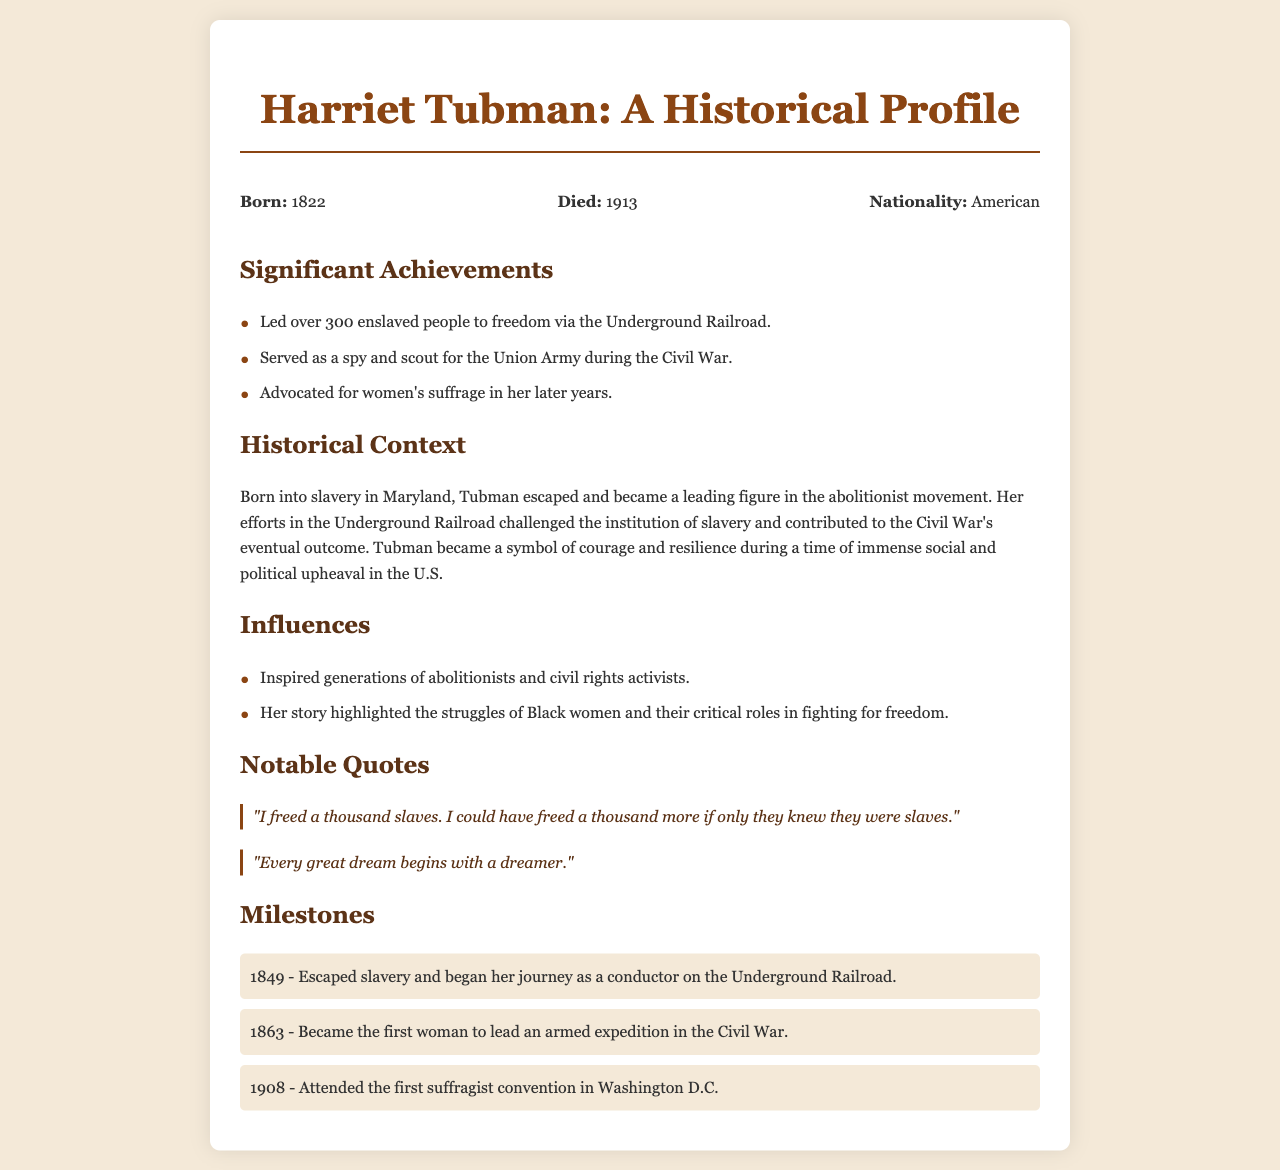What year was Harriet Tubman born? The document states that Harriet Tubman was born in 1822.
Answer: 1822 What role did Harriet Tubman serve in the Civil War? The document indicates that she served as a spy and scout for the Union Army during the Civil War.
Answer: Spy and scout How many enslaved people did Harriet Tubman lead to freedom? According to the document, Harriet Tubman led over 300 enslaved people to freedom via the Underground Railroad.
Answer: Over 300 What notable event occurred in 1863? The document mentions that in 1863, Harriet Tubman became the first woman to lead an armed expedition in the Civil War.
Answer: First woman to lead an armed expedition What is described as Harriet Tubman's significant influence? The document states that she inspired generations of abolitionists and civil rights activists.
Answer: Inspired generations What major theme is highlighted about Harriet Tubman's life? The document emphasizes her role in challenging the institution of slavery and her significance during social and political upheaval.
Answer: Challenging slavery What does the quote "I freed a thousand slaves..." imply about her perspective? The document's quote reflects Tubman's view on the awareness of enslaved individuals regarding their status and freedom.
Answer: Awareness of their status 